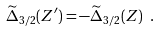Convert formula to latex. <formula><loc_0><loc_0><loc_500><loc_500>\widetilde { \Delta } _ { 3 / 2 } ( Z ^ { \prime } ) = - \widetilde { \Delta } _ { 3 / 2 } ( Z ) \ .</formula> 